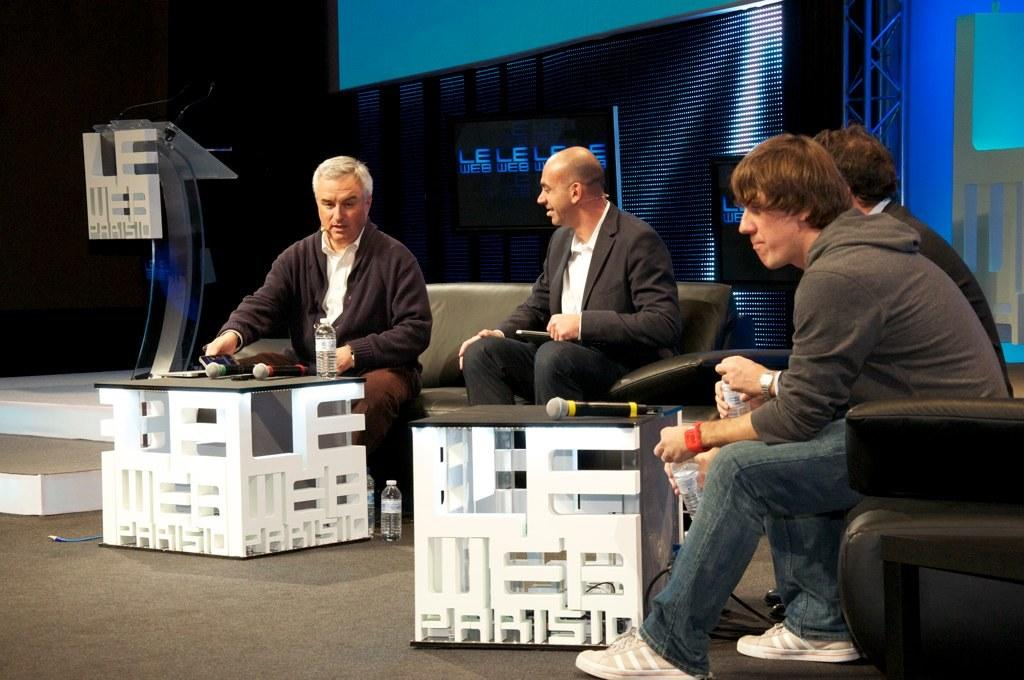<image>
Share a concise interpretation of the image provided. Men sit around two coffee tables that are carved to spell Le Web Paris on the sides. 